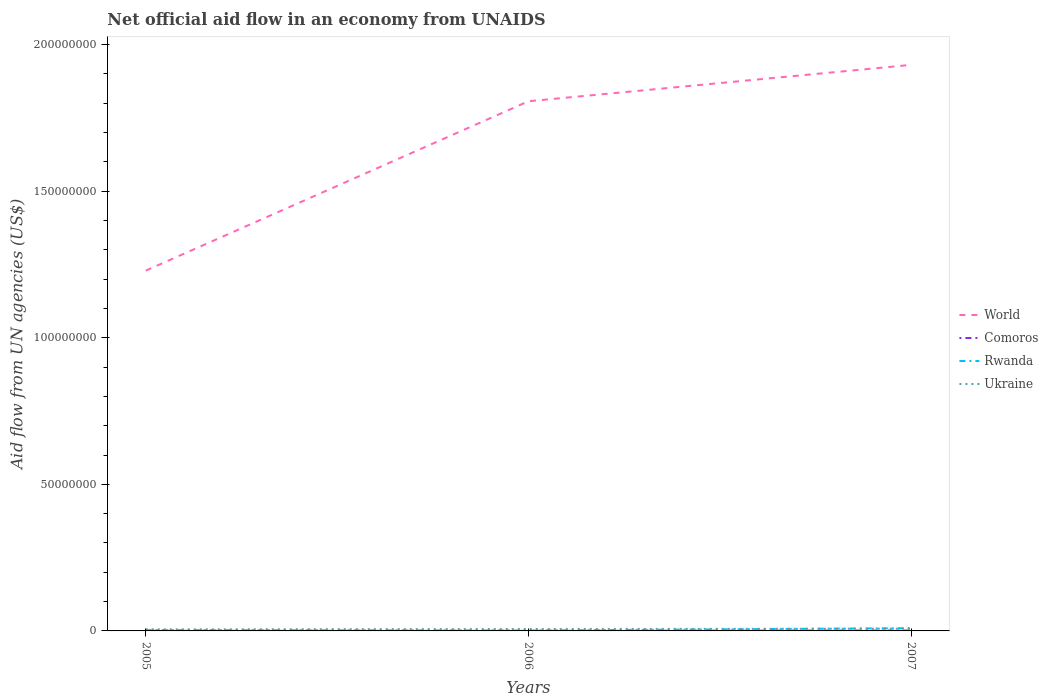Does the line corresponding to World intersect with the line corresponding to Ukraine?
Give a very brief answer. No. Across all years, what is the maximum net official aid flow in World?
Provide a succinct answer. 1.23e+08. What is the total net official aid flow in World in the graph?
Make the answer very short. -7.02e+07. What is the difference between the highest and the second highest net official aid flow in Ukraine?
Your answer should be very brief. 2.30e+05. What is the difference between the highest and the lowest net official aid flow in Comoros?
Your answer should be compact. 1. What is the difference between two consecutive major ticks on the Y-axis?
Provide a succinct answer. 5.00e+07. Does the graph contain any zero values?
Provide a short and direct response. No. Where does the legend appear in the graph?
Offer a terse response. Center right. What is the title of the graph?
Offer a terse response. Net official aid flow in an economy from UNAIDS. Does "Czech Republic" appear as one of the legend labels in the graph?
Give a very brief answer. No. What is the label or title of the X-axis?
Offer a terse response. Years. What is the label or title of the Y-axis?
Make the answer very short. Aid flow from UN agencies (US$). What is the Aid flow from UN agencies (US$) in World in 2005?
Ensure brevity in your answer.  1.23e+08. What is the Aid flow from UN agencies (US$) of Ukraine in 2005?
Offer a terse response. 5.30e+05. What is the Aid flow from UN agencies (US$) in World in 2006?
Offer a very short reply. 1.81e+08. What is the Aid flow from UN agencies (US$) of Comoros in 2006?
Your answer should be compact. 2.00e+04. What is the Aid flow from UN agencies (US$) of Ukraine in 2006?
Your response must be concise. 6.50e+05. What is the Aid flow from UN agencies (US$) of World in 2007?
Make the answer very short. 1.93e+08. What is the Aid flow from UN agencies (US$) in Comoros in 2007?
Offer a terse response. 1.40e+05. What is the Aid flow from UN agencies (US$) in Rwanda in 2007?
Ensure brevity in your answer.  9.40e+05. What is the Aid flow from UN agencies (US$) of Ukraine in 2007?
Provide a succinct answer. 7.60e+05. Across all years, what is the maximum Aid flow from UN agencies (US$) in World?
Your answer should be compact. 1.93e+08. Across all years, what is the maximum Aid flow from UN agencies (US$) in Rwanda?
Offer a terse response. 9.40e+05. Across all years, what is the maximum Aid flow from UN agencies (US$) in Ukraine?
Your answer should be very brief. 7.60e+05. Across all years, what is the minimum Aid flow from UN agencies (US$) in World?
Give a very brief answer. 1.23e+08. Across all years, what is the minimum Aid flow from UN agencies (US$) of Comoros?
Keep it short and to the point. 2.00e+04. Across all years, what is the minimum Aid flow from UN agencies (US$) of Rwanda?
Keep it short and to the point. 1.40e+05. Across all years, what is the minimum Aid flow from UN agencies (US$) of Ukraine?
Provide a short and direct response. 5.30e+05. What is the total Aid flow from UN agencies (US$) of World in the graph?
Ensure brevity in your answer.  4.97e+08. What is the total Aid flow from UN agencies (US$) in Rwanda in the graph?
Provide a short and direct response. 1.37e+06. What is the total Aid flow from UN agencies (US$) of Ukraine in the graph?
Give a very brief answer. 1.94e+06. What is the difference between the Aid flow from UN agencies (US$) in World in 2005 and that in 2006?
Give a very brief answer. -5.78e+07. What is the difference between the Aid flow from UN agencies (US$) in Comoros in 2005 and that in 2006?
Make the answer very short. 3.00e+04. What is the difference between the Aid flow from UN agencies (US$) of Rwanda in 2005 and that in 2006?
Offer a very short reply. 1.50e+05. What is the difference between the Aid flow from UN agencies (US$) of World in 2005 and that in 2007?
Your answer should be very brief. -7.02e+07. What is the difference between the Aid flow from UN agencies (US$) of Comoros in 2005 and that in 2007?
Ensure brevity in your answer.  -9.00e+04. What is the difference between the Aid flow from UN agencies (US$) of Rwanda in 2005 and that in 2007?
Provide a succinct answer. -6.50e+05. What is the difference between the Aid flow from UN agencies (US$) in Ukraine in 2005 and that in 2007?
Make the answer very short. -2.30e+05. What is the difference between the Aid flow from UN agencies (US$) of World in 2006 and that in 2007?
Provide a short and direct response. -1.24e+07. What is the difference between the Aid flow from UN agencies (US$) in Rwanda in 2006 and that in 2007?
Your answer should be compact. -8.00e+05. What is the difference between the Aid flow from UN agencies (US$) in World in 2005 and the Aid flow from UN agencies (US$) in Comoros in 2006?
Offer a very short reply. 1.23e+08. What is the difference between the Aid flow from UN agencies (US$) of World in 2005 and the Aid flow from UN agencies (US$) of Rwanda in 2006?
Offer a very short reply. 1.23e+08. What is the difference between the Aid flow from UN agencies (US$) in World in 2005 and the Aid flow from UN agencies (US$) in Ukraine in 2006?
Provide a succinct answer. 1.22e+08. What is the difference between the Aid flow from UN agencies (US$) of Comoros in 2005 and the Aid flow from UN agencies (US$) of Rwanda in 2006?
Your answer should be compact. -9.00e+04. What is the difference between the Aid flow from UN agencies (US$) of Comoros in 2005 and the Aid flow from UN agencies (US$) of Ukraine in 2006?
Your answer should be compact. -6.00e+05. What is the difference between the Aid flow from UN agencies (US$) of Rwanda in 2005 and the Aid flow from UN agencies (US$) of Ukraine in 2006?
Offer a terse response. -3.60e+05. What is the difference between the Aid flow from UN agencies (US$) of World in 2005 and the Aid flow from UN agencies (US$) of Comoros in 2007?
Your response must be concise. 1.23e+08. What is the difference between the Aid flow from UN agencies (US$) in World in 2005 and the Aid flow from UN agencies (US$) in Rwanda in 2007?
Ensure brevity in your answer.  1.22e+08. What is the difference between the Aid flow from UN agencies (US$) of World in 2005 and the Aid flow from UN agencies (US$) of Ukraine in 2007?
Make the answer very short. 1.22e+08. What is the difference between the Aid flow from UN agencies (US$) in Comoros in 2005 and the Aid flow from UN agencies (US$) in Rwanda in 2007?
Provide a succinct answer. -8.90e+05. What is the difference between the Aid flow from UN agencies (US$) of Comoros in 2005 and the Aid flow from UN agencies (US$) of Ukraine in 2007?
Ensure brevity in your answer.  -7.10e+05. What is the difference between the Aid flow from UN agencies (US$) of Rwanda in 2005 and the Aid flow from UN agencies (US$) of Ukraine in 2007?
Keep it short and to the point. -4.70e+05. What is the difference between the Aid flow from UN agencies (US$) of World in 2006 and the Aid flow from UN agencies (US$) of Comoros in 2007?
Make the answer very short. 1.81e+08. What is the difference between the Aid flow from UN agencies (US$) of World in 2006 and the Aid flow from UN agencies (US$) of Rwanda in 2007?
Make the answer very short. 1.80e+08. What is the difference between the Aid flow from UN agencies (US$) of World in 2006 and the Aid flow from UN agencies (US$) of Ukraine in 2007?
Your answer should be compact. 1.80e+08. What is the difference between the Aid flow from UN agencies (US$) in Comoros in 2006 and the Aid flow from UN agencies (US$) in Rwanda in 2007?
Offer a very short reply. -9.20e+05. What is the difference between the Aid flow from UN agencies (US$) of Comoros in 2006 and the Aid flow from UN agencies (US$) of Ukraine in 2007?
Your answer should be very brief. -7.40e+05. What is the difference between the Aid flow from UN agencies (US$) in Rwanda in 2006 and the Aid flow from UN agencies (US$) in Ukraine in 2007?
Your answer should be very brief. -6.20e+05. What is the average Aid flow from UN agencies (US$) of World per year?
Offer a very short reply. 1.66e+08. What is the average Aid flow from UN agencies (US$) of Comoros per year?
Provide a succinct answer. 7.00e+04. What is the average Aid flow from UN agencies (US$) in Rwanda per year?
Offer a terse response. 4.57e+05. What is the average Aid flow from UN agencies (US$) in Ukraine per year?
Your answer should be compact. 6.47e+05. In the year 2005, what is the difference between the Aid flow from UN agencies (US$) in World and Aid flow from UN agencies (US$) in Comoros?
Make the answer very short. 1.23e+08. In the year 2005, what is the difference between the Aid flow from UN agencies (US$) in World and Aid flow from UN agencies (US$) in Rwanda?
Make the answer very short. 1.23e+08. In the year 2005, what is the difference between the Aid flow from UN agencies (US$) of World and Aid flow from UN agencies (US$) of Ukraine?
Provide a short and direct response. 1.22e+08. In the year 2005, what is the difference between the Aid flow from UN agencies (US$) of Comoros and Aid flow from UN agencies (US$) of Ukraine?
Offer a very short reply. -4.80e+05. In the year 2005, what is the difference between the Aid flow from UN agencies (US$) in Rwanda and Aid flow from UN agencies (US$) in Ukraine?
Your answer should be very brief. -2.40e+05. In the year 2006, what is the difference between the Aid flow from UN agencies (US$) in World and Aid flow from UN agencies (US$) in Comoros?
Offer a very short reply. 1.81e+08. In the year 2006, what is the difference between the Aid flow from UN agencies (US$) in World and Aid flow from UN agencies (US$) in Rwanda?
Keep it short and to the point. 1.81e+08. In the year 2006, what is the difference between the Aid flow from UN agencies (US$) in World and Aid flow from UN agencies (US$) in Ukraine?
Your answer should be compact. 1.80e+08. In the year 2006, what is the difference between the Aid flow from UN agencies (US$) of Comoros and Aid flow from UN agencies (US$) of Ukraine?
Offer a very short reply. -6.30e+05. In the year 2006, what is the difference between the Aid flow from UN agencies (US$) in Rwanda and Aid flow from UN agencies (US$) in Ukraine?
Offer a terse response. -5.10e+05. In the year 2007, what is the difference between the Aid flow from UN agencies (US$) of World and Aid flow from UN agencies (US$) of Comoros?
Provide a short and direct response. 1.93e+08. In the year 2007, what is the difference between the Aid flow from UN agencies (US$) in World and Aid flow from UN agencies (US$) in Rwanda?
Offer a terse response. 1.92e+08. In the year 2007, what is the difference between the Aid flow from UN agencies (US$) of World and Aid flow from UN agencies (US$) of Ukraine?
Your response must be concise. 1.92e+08. In the year 2007, what is the difference between the Aid flow from UN agencies (US$) of Comoros and Aid flow from UN agencies (US$) of Rwanda?
Offer a terse response. -8.00e+05. In the year 2007, what is the difference between the Aid flow from UN agencies (US$) of Comoros and Aid flow from UN agencies (US$) of Ukraine?
Your answer should be compact. -6.20e+05. What is the ratio of the Aid flow from UN agencies (US$) of World in 2005 to that in 2006?
Offer a terse response. 0.68. What is the ratio of the Aid flow from UN agencies (US$) of Comoros in 2005 to that in 2006?
Ensure brevity in your answer.  2.5. What is the ratio of the Aid flow from UN agencies (US$) in Rwanda in 2005 to that in 2006?
Your answer should be very brief. 2.07. What is the ratio of the Aid flow from UN agencies (US$) of Ukraine in 2005 to that in 2006?
Make the answer very short. 0.82. What is the ratio of the Aid flow from UN agencies (US$) of World in 2005 to that in 2007?
Offer a very short reply. 0.64. What is the ratio of the Aid flow from UN agencies (US$) of Comoros in 2005 to that in 2007?
Keep it short and to the point. 0.36. What is the ratio of the Aid flow from UN agencies (US$) of Rwanda in 2005 to that in 2007?
Offer a terse response. 0.31. What is the ratio of the Aid flow from UN agencies (US$) of Ukraine in 2005 to that in 2007?
Your answer should be very brief. 0.7. What is the ratio of the Aid flow from UN agencies (US$) of World in 2006 to that in 2007?
Offer a very short reply. 0.94. What is the ratio of the Aid flow from UN agencies (US$) of Comoros in 2006 to that in 2007?
Your answer should be very brief. 0.14. What is the ratio of the Aid flow from UN agencies (US$) of Rwanda in 2006 to that in 2007?
Your answer should be compact. 0.15. What is the ratio of the Aid flow from UN agencies (US$) in Ukraine in 2006 to that in 2007?
Your response must be concise. 0.86. What is the difference between the highest and the second highest Aid flow from UN agencies (US$) of World?
Ensure brevity in your answer.  1.24e+07. What is the difference between the highest and the second highest Aid flow from UN agencies (US$) in Rwanda?
Your response must be concise. 6.50e+05. What is the difference between the highest and the second highest Aid flow from UN agencies (US$) in Ukraine?
Keep it short and to the point. 1.10e+05. What is the difference between the highest and the lowest Aid flow from UN agencies (US$) in World?
Keep it short and to the point. 7.02e+07. What is the difference between the highest and the lowest Aid flow from UN agencies (US$) of Rwanda?
Provide a succinct answer. 8.00e+05. What is the difference between the highest and the lowest Aid flow from UN agencies (US$) of Ukraine?
Your answer should be compact. 2.30e+05. 